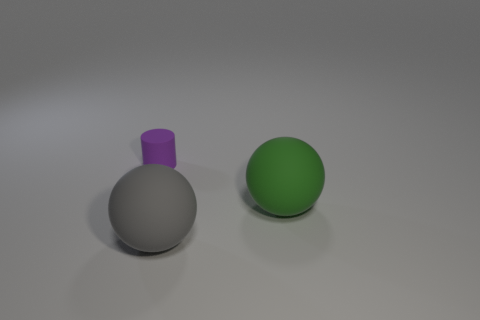Subtract 1 balls. How many balls are left? 1 Add 3 matte balls. How many objects exist? 6 Subtract all yellow spheres. Subtract all brown cubes. How many spheres are left? 2 Subtract all red cylinders. How many gray spheres are left? 1 Subtract all cylinders. Subtract all green rubber objects. How many objects are left? 1 Add 1 purple cylinders. How many purple cylinders are left? 2 Add 1 big cyan rubber balls. How many big cyan rubber balls exist? 1 Subtract 0 blue cylinders. How many objects are left? 3 Subtract all spheres. How many objects are left? 1 